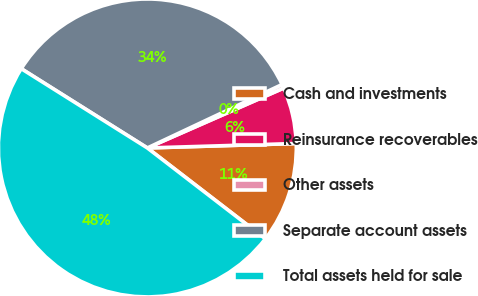<chart> <loc_0><loc_0><loc_500><loc_500><pie_chart><fcel>Cash and investments<fcel>Reinsurance recoverables<fcel>Other assets<fcel>Separate account assets<fcel>Total assets held for sale<nl><fcel>10.92%<fcel>6.11%<fcel>0.42%<fcel>34.06%<fcel>48.49%<nl></chart> 